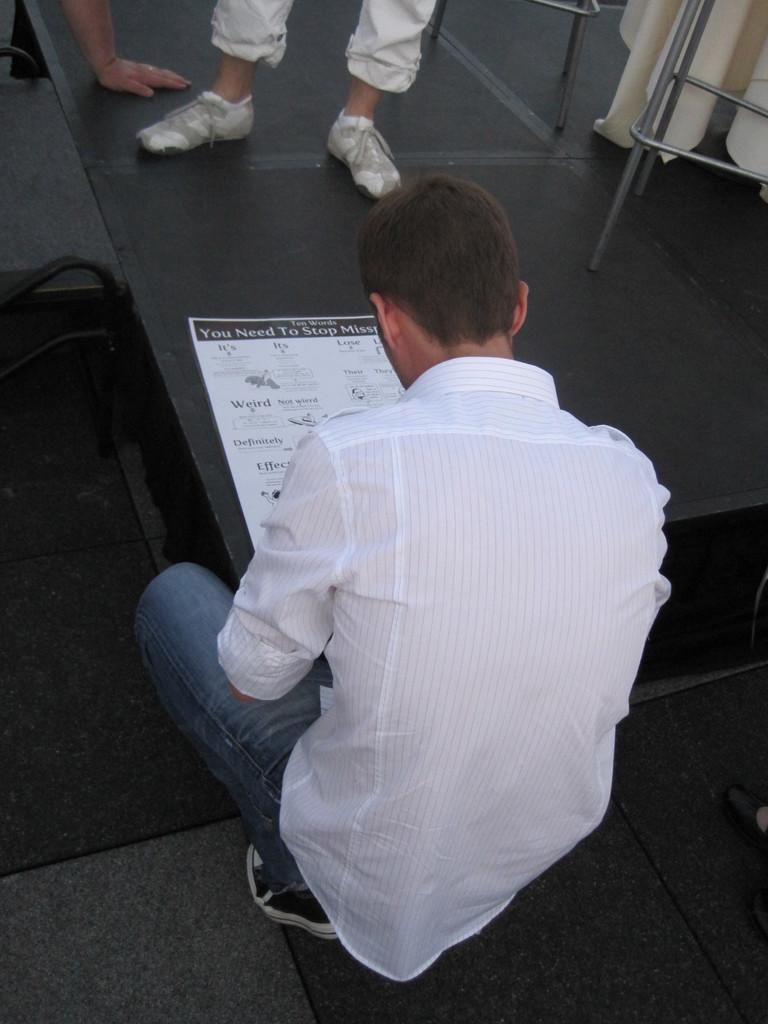Can you describe this image briefly? In this image I can see a person sitting beside the bench where we can see a paper, also there is another person and stand at the back. 